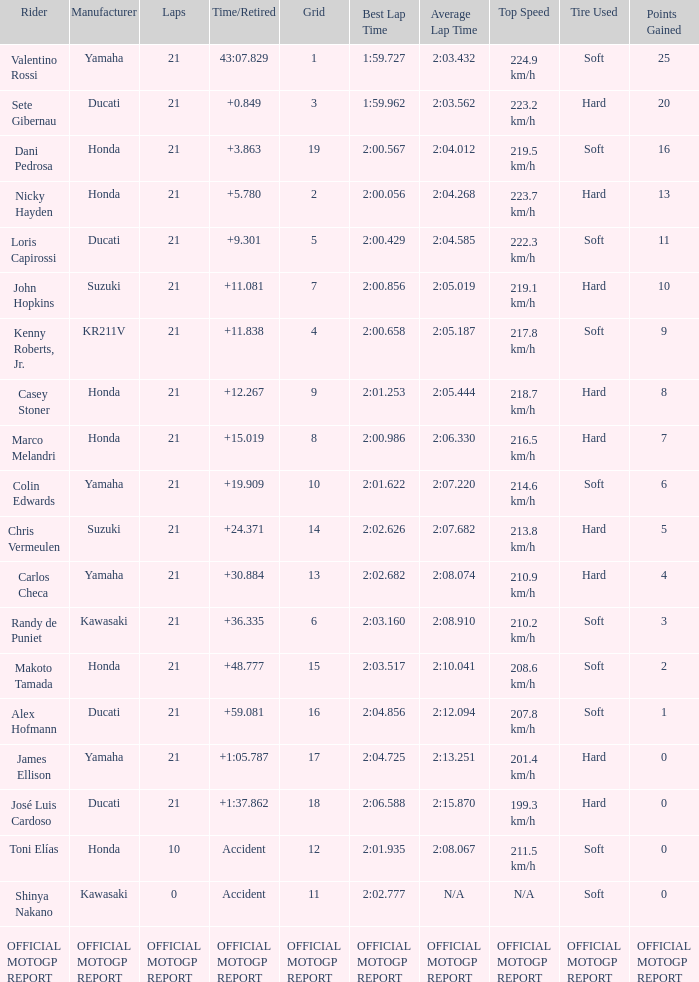What was the amount of laps for the vehicle manufactured by honda with a grid of 9? 21.0. 